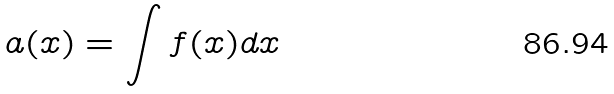Convert formula to latex. <formula><loc_0><loc_0><loc_500><loc_500>a ( x ) = \int f ( x ) d x</formula> 